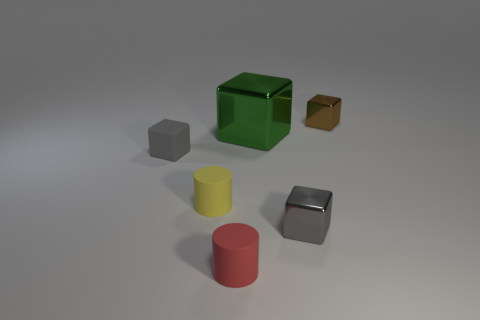How many tiny brown objects have the same material as the big green thing?
Your response must be concise. 1. What is the color of the small thing in front of the small gray block that is in front of the small block to the left of the green cube?
Your answer should be very brief. Red. Is the size of the red object the same as the green cube?
Give a very brief answer. No. Are there any other things that are the same shape as the tiny brown thing?
Offer a very short reply. Yes. How many things are either matte cylinders behind the small gray shiny thing or tiny matte objects?
Provide a short and direct response. 3. Is the red thing the same shape as the tiny brown metallic thing?
Provide a short and direct response. No. What number of other objects are there of the same size as the gray rubber thing?
Keep it short and to the point. 4. What color is the tiny rubber block?
Provide a short and direct response. Gray. How many small objects are blue metal cubes or matte things?
Keep it short and to the point. 3. Is the size of the metal thing in front of the small gray rubber object the same as the object behind the large metallic object?
Your answer should be very brief. Yes. 